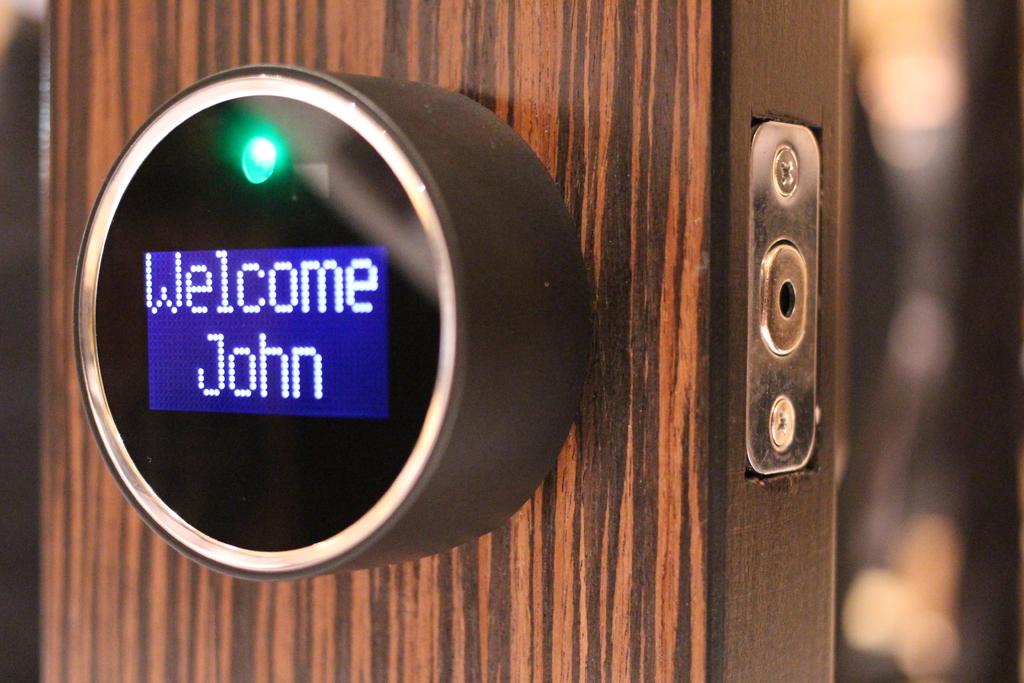Who is the object welcoming?
Offer a terse response. John. What is the first word on the top of the screen?
Provide a short and direct response. Welcome. 